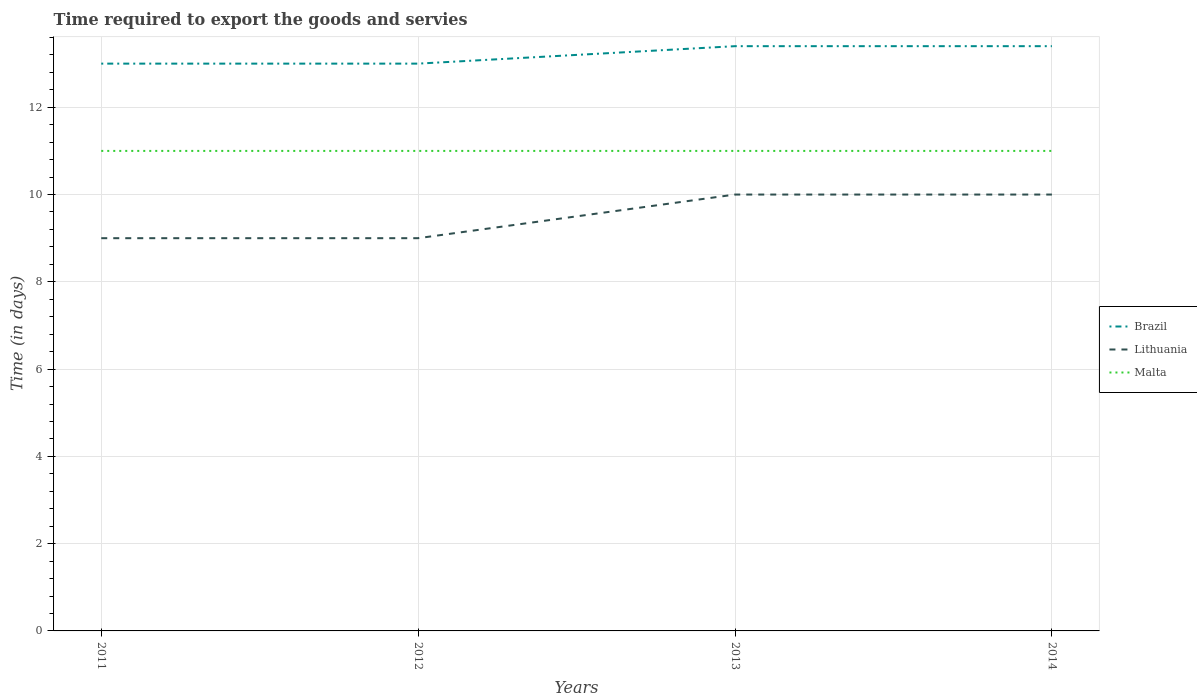Across all years, what is the maximum number of days required to export the goods and services in Malta?
Give a very brief answer. 11. What is the total number of days required to export the goods and services in Brazil in the graph?
Your answer should be compact. -0.4. What is the difference between the highest and the second highest number of days required to export the goods and services in Malta?
Make the answer very short. 0. What is the difference between the highest and the lowest number of days required to export the goods and services in Malta?
Your response must be concise. 0. How many lines are there?
Your answer should be compact. 3. How many years are there in the graph?
Your answer should be very brief. 4. Does the graph contain any zero values?
Keep it short and to the point. No. How many legend labels are there?
Provide a short and direct response. 3. What is the title of the graph?
Give a very brief answer. Time required to export the goods and servies. What is the label or title of the X-axis?
Your answer should be very brief. Years. What is the label or title of the Y-axis?
Offer a terse response. Time (in days). What is the Time (in days) of Brazil in 2011?
Offer a terse response. 13. What is the Time (in days) of Malta in 2011?
Your answer should be compact. 11. What is the Time (in days) in Brazil in 2013?
Keep it short and to the point. 13.4. What is the Time (in days) in Brazil in 2014?
Your response must be concise. 13.4. What is the Time (in days) in Malta in 2014?
Give a very brief answer. 11. Across all years, what is the maximum Time (in days) in Brazil?
Your answer should be very brief. 13.4. Across all years, what is the minimum Time (in days) of Malta?
Ensure brevity in your answer.  11. What is the total Time (in days) in Brazil in the graph?
Make the answer very short. 52.8. What is the total Time (in days) of Lithuania in the graph?
Give a very brief answer. 38. What is the total Time (in days) of Malta in the graph?
Give a very brief answer. 44. What is the difference between the Time (in days) in Brazil in 2011 and that in 2012?
Ensure brevity in your answer.  0. What is the difference between the Time (in days) in Malta in 2011 and that in 2012?
Give a very brief answer. 0. What is the difference between the Time (in days) in Brazil in 2011 and that in 2013?
Provide a short and direct response. -0.4. What is the difference between the Time (in days) of Lithuania in 2011 and that in 2013?
Provide a short and direct response. -1. What is the difference between the Time (in days) of Brazil in 2011 and that in 2014?
Provide a short and direct response. -0.4. What is the difference between the Time (in days) of Malta in 2011 and that in 2014?
Keep it short and to the point. 0. What is the difference between the Time (in days) of Brazil in 2012 and that in 2013?
Provide a short and direct response. -0.4. What is the difference between the Time (in days) of Malta in 2012 and that in 2013?
Your response must be concise. 0. What is the difference between the Time (in days) of Brazil in 2013 and that in 2014?
Offer a terse response. 0. What is the difference between the Time (in days) in Lithuania in 2013 and that in 2014?
Provide a short and direct response. 0. What is the difference between the Time (in days) in Brazil in 2011 and the Time (in days) in Malta in 2012?
Give a very brief answer. 2. What is the difference between the Time (in days) of Lithuania in 2011 and the Time (in days) of Malta in 2012?
Your answer should be compact. -2. What is the difference between the Time (in days) in Brazil in 2011 and the Time (in days) in Lithuania in 2013?
Your answer should be very brief. 3. What is the difference between the Time (in days) of Brazil in 2011 and the Time (in days) of Malta in 2013?
Your answer should be very brief. 2. What is the difference between the Time (in days) in Brazil in 2011 and the Time (in days) in Lithuania in 2014?
Your answer should be compact. 3. What is the difference between the Time (in days) of Brazil in 2011 and the Time (in days) of Malta in 2014?
Give a very brief answer. 2. What is the difference between the Time (in days) in Lithuania in 2011 and the Time (in days) in Malta in 2014?
Offer a terse response. -2. What is the difference between the Time (in days) in Lithuania in 2012 and the Time (in days) in Malta in 2013?
Keep it short and to the point. -2. What is the difference between the Time (in days) of Lithuania in 2012 and the Time (in days) of Malta in 2014?
Give a very brief answer. -2. What is the difference between the Time (in days) of Brazil in 2013 and the Time (in days) of Lithuania in 2014?
Provide a succinct answer. 3.4. What is the difference between the Time (in days) of Brazil in 2013 and the Time (in days) of Malta in 2014?
Keep it short and to the point. 2.4. What is the difference between the Time (in days) in Lithuania in 2013 and the Time (in days) in Malta in 2014?
Provide a short and direct response. -1. What is the average Time (in days) in Lithuania per year?
Give a very brief answer. 9.5. What is the average Time (in days) in Malta per year?
Keep it short and to the point. 11. In the year 2011, what is the difference between the Time (in days) in Brazil and Time (in days) in Malta?
Make the answer very short. 2. In the year 2013, what is the difference between the Time (in days) in Brazil and Time (in days) in Malta?
Keep it short and to the point. 2.4. In the year 2014, what is the difference between the Time (in days) of Brazil and Time (in days) of Malta?
Your response must be concise. 2.4. What is the ratio of the Time (in days) of Malta in 2011 to that in 2012?
Ensure brevity in your answer.  1. What is the ratio of the Time (in days) of Brazil in 2011 to that in 2013?
Offer a terse response. 0.97. What is the ratio of the Time (in days) in Lithuania in 2011 to that in 2013?
Provide a succinct answer. 0.9. What is the ratio of the Time (in days) of Malta in 2011 to that in 2013?
Keep it short and to the point. 1. What is the ratio of the Time (in days) of Brazil in 2011 to that in 2014?
Give a very brief answer. 0.97. What is the ratio of the Time (in days) of Lithuania in 2011 to that in 2014?
Provide a short and direct response. 0.9. What is the ratio of the Time (in days) in Malta in 2011 to that in 2014?
Ensure brevity in your answer.  1. What is the ratio of the Time (in days) in Brazil in 2012 to that in 2013?
Make the answer very short. 0.97. What is the ratio of the Time (in days) of Lithuania in 2012 to that in 2013?
Your response must be concise. 0.9. What is the ratio of the Time (in days) in Brazil in 2012 to that in 2014?
Make the answer very short. 0.97. What is the ratio of the Time (in days) in Malta in 2012 to that in 2014?
Ensure brevity in your answer.  1. What is the ratio of the Time (in days) in Brazil in 2013 to that in 2014?
Provide a short and direct response. 1. What is the ratio of the Time (in days) in Lithuania in 2013 to that in 2014?
Your response must be concise. 1. What is the ratio of the Time (in days) in Malta in 2013 to that in 2014?
Ensure brevity in your answer.  1. What is the difference between the highest and the second highest Time (in days) of Brazil?
Make the answer very short. 0. What is the difference between the highest and the lowest Time (in days) of Brazil?
Offer a terse response. 0.4. What is the difference between the highest and the lowest Time (in days) of Malta?
Your answer should be very brief. 0. 